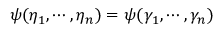Convert formula to latex. <formula><loc_0><loc_0><loc_500><loc_500>\psi ( \eta _ { 1 } , \cdots , \eta _ { n } ) = \psi ( \gamma _ { 1 } , \cdots , \gamma _ { n } )</formula> 